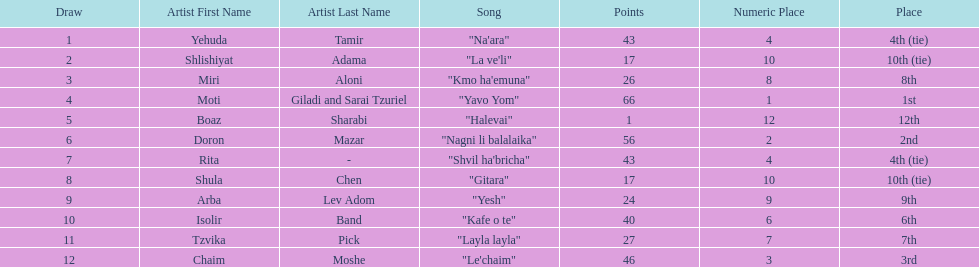What is the name of the first song listed on this chart? "Na'ara". Help me parse the entirety of this table. {'header': ['Draw', 'Artist First Name', 'Artist Last Name', 'Song', 'Points', 'Numeric Place', 'Place'], 'rows': [['1', 'Yehuda', 'Tamir', '"Na\'ara"', '43', '4', '4th (tie)'], ['2', 'Shlishiyat', 'Adama', '"La ve\'li"', '17', '10', '10th (tie)'], ['3', 'Miri', 'Aloni', '"Kmo ha\'emuna"', '26', '8', '8th'], ['4', 'Moti', 'Giladi and Sarai Tzuriel', '"Yavo Yom"', '66', '1', '1st'], ['5', 'Boaz', 'Sharabi', '"Halevai"', '1', '12', '12th'], ['6', 'Doron', 'Mazar', '"Nagni li balalaika"', '56', '2', '2nd'], ['7', 'Rita', '-', '"Shvil ha\'bricha"', '43', '4', '4th (tie)'], ['8', 'Shula', 'Chen', '"Gitara"', '17', '10', '10th (tie)'], ['9', 'Arba', 'Lev Adom', '"Yesh"', '24', '9', '9th'], ['10', 'Isolir', 'Band', '"Kafe o te"', '40', '6', '6th'], ['11', 'Tzvika', 'Pick', '"Layla layla"', '27', '7', '7th'], ['12', 'Chaim', 'Moshe', '"Le\'chaim"', '46', '3', '3rd']]} 